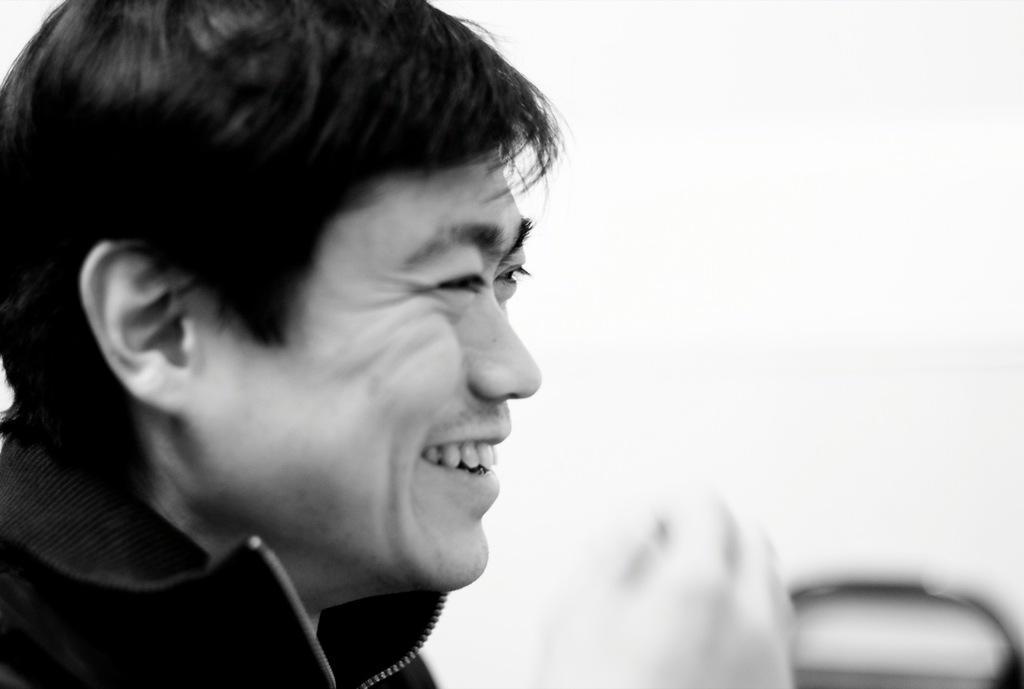In one or two sentences, can you explain what this image depicts? This is a black and white image in this image there is a man. 